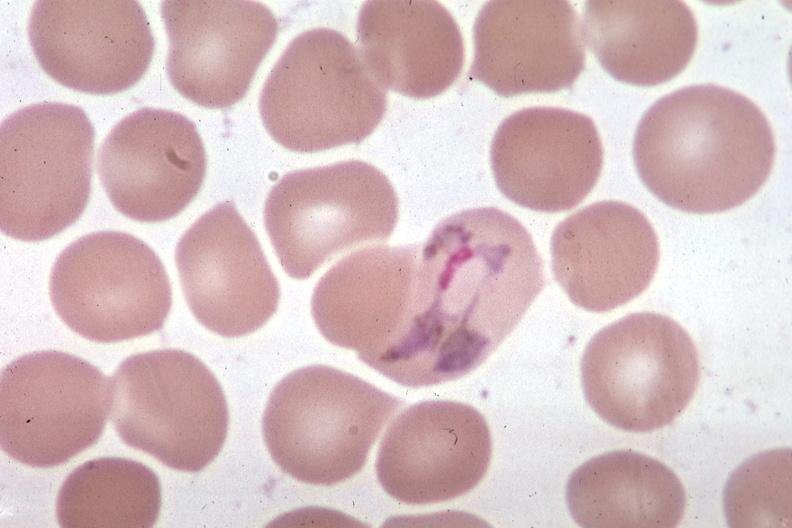what does this image show?
Answer the question using a single word or phrase. Wrights excellent 